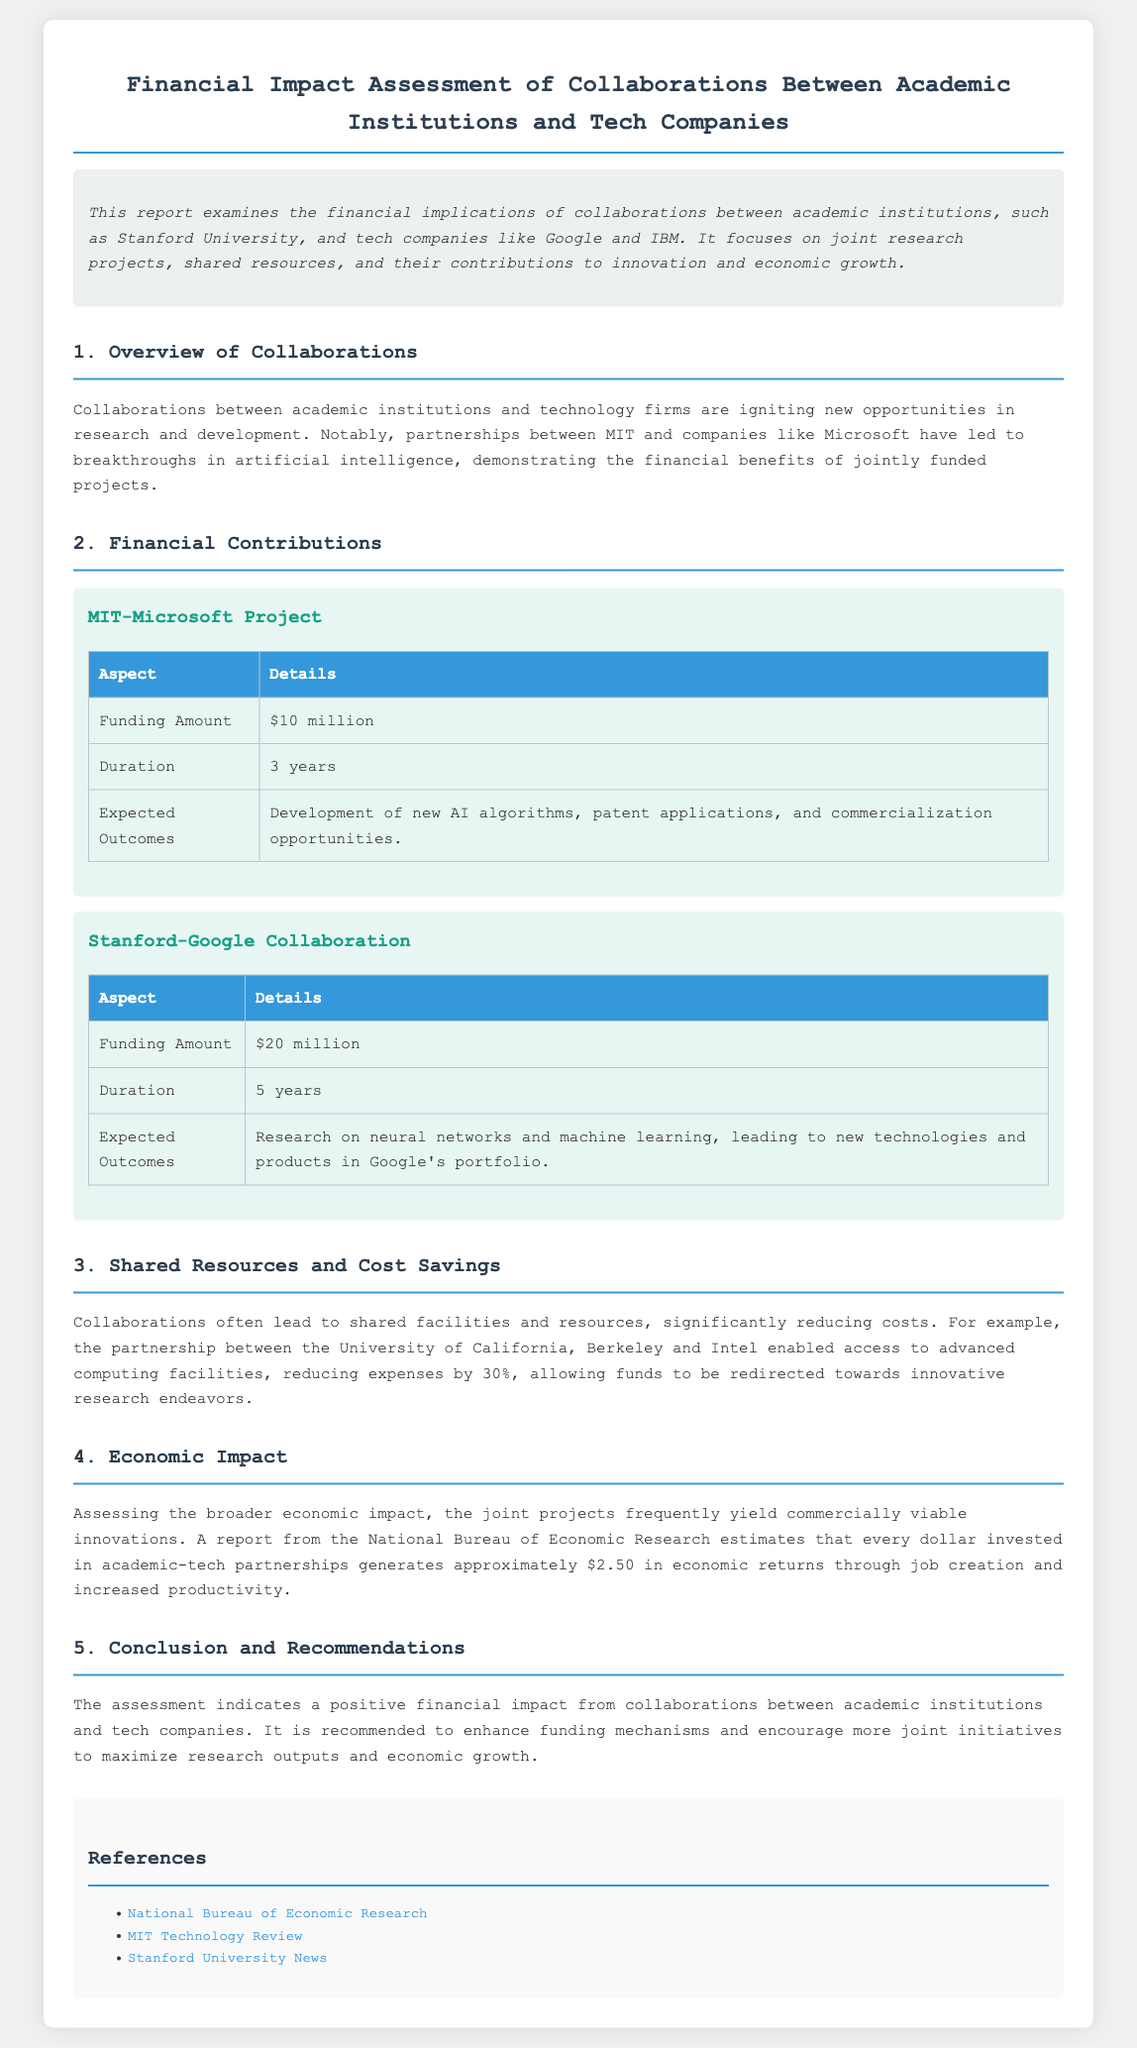What is the funding amount for the MIT-Microsoft project? The funding amount for the MIT-Microsoft project is explicitly stated in the document.
Answer: $10 million What is the expected outcome of the Stanford-Google collaboration? The expected outcomes are listed in the context.
Answer: Research on neural networks and machine learning, leading to new technologies and products in Google's portfolio How much cost reduction was achieved in the University of California, Berkeley and Intel partnership? The document mentions a specific percentage of cost savings achieved.
Answer: 30% What is the duration of the Stanford-Google collaboration? The duration of the collaboration is provided in the respective section of the document.
Answer: 5 years What economic return is estimated for every dollar invested in academic-tech partnerships? The document includes an estimate of the economic return per dollar invested.
Answer: $2.50 What is the main recommendation made in the report? The report concludes with a key recommendation aimed at improving collaborations.
Answer: Enhance funding mechanisms and encourage more joint initiatives Which institution collaborated with Microsoft in the document? The document references a specific institution collaborating with Microsoft.
Answer: MIT What is the title of the document? The title summarizing the contents of the report is stated at the beginning.
Answer: Financial Impact Assessment of Collaborations Between Academic Institutions and Tech Companies 